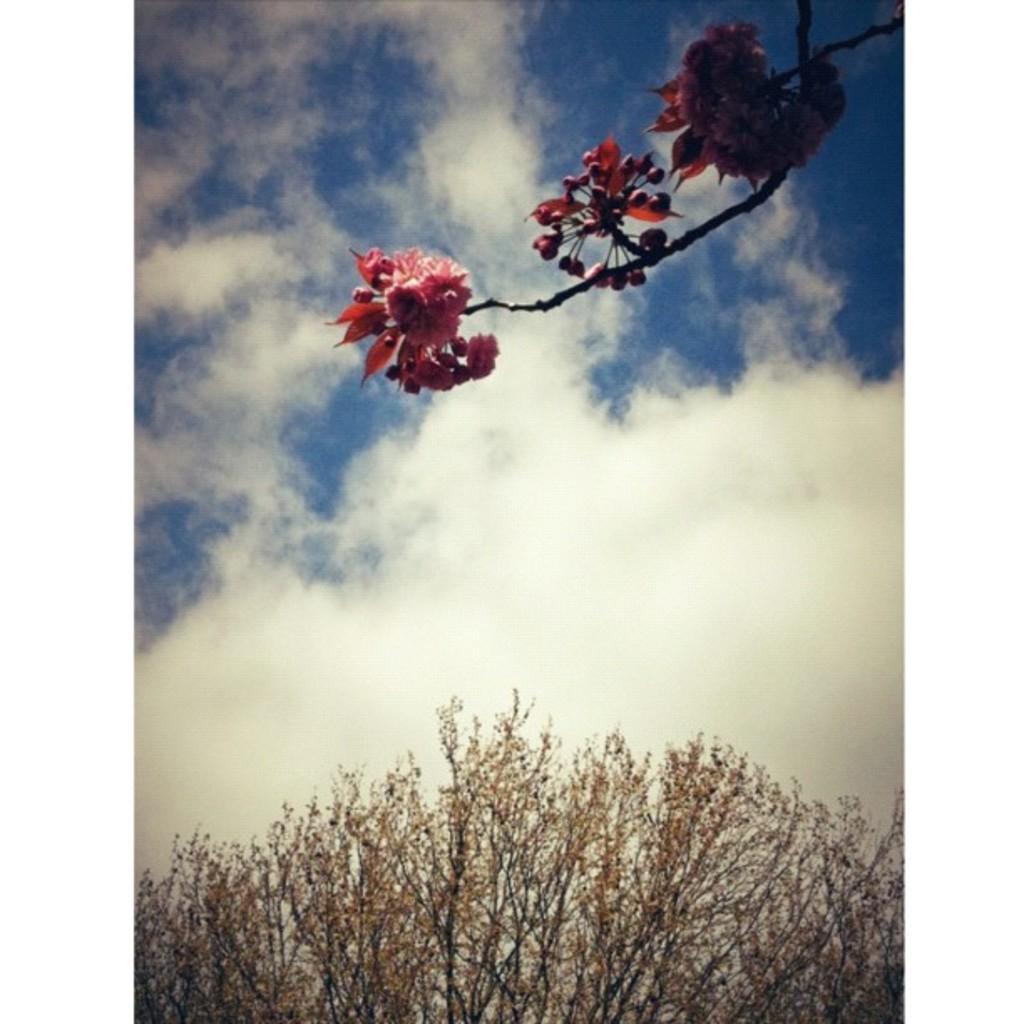Can you describe this image briefly? In this image, I can see a stem with the flowers. These are the clouds in the sky. At the bottom of the image, these look like the dried plants. 